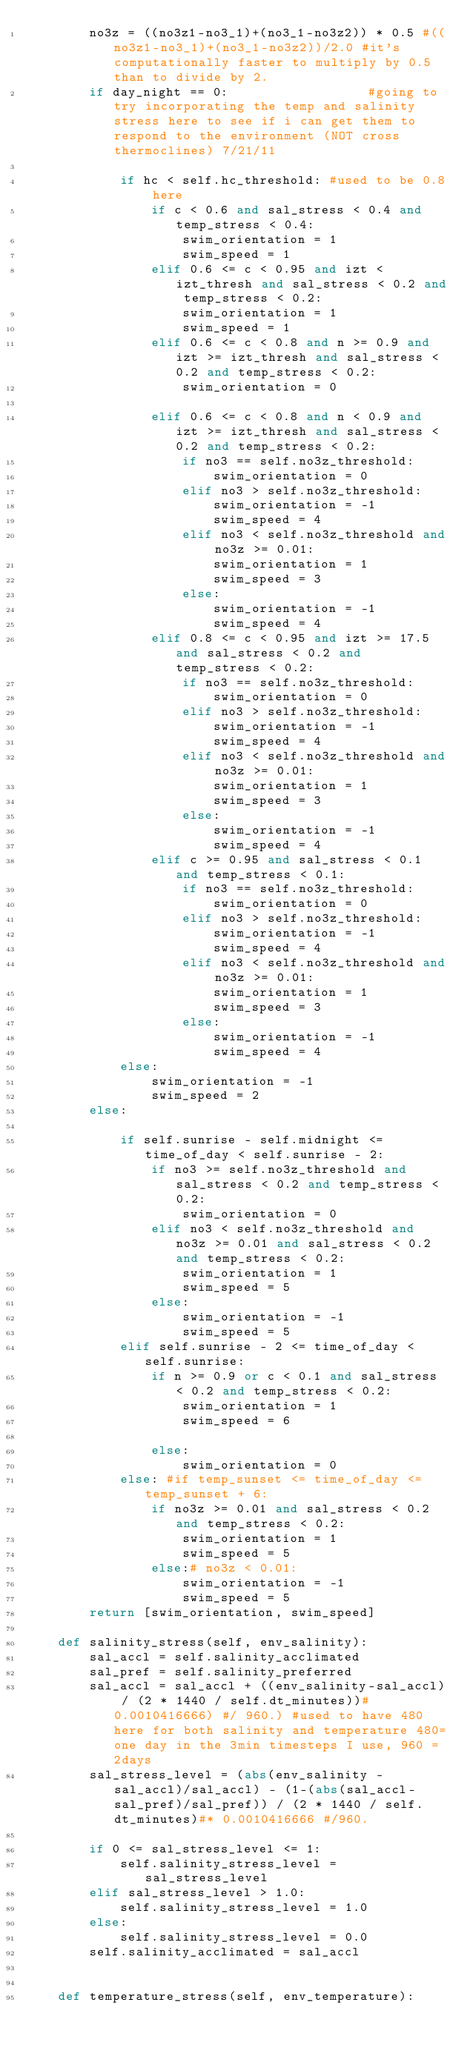Convert code to text. <code><loc_0><loc_0><loc_500><loc_500><_Python_>        no3z = ((no3z1-no3_1)+(no3_1-no3z2)) * 0.5 #((no3z1-no3_1)+(no3_1-no3z2))/2.0 #it's computationally faster to multiply by 0.5 than to divide by 2.
        if day_night == 0:                  #going to try incorporating the temp and salinity stress here to see if i can get them to respond to the environment (NOT cross thermoclines) 7/21/11
            
            if hc < self.hc_threshold: #used to be 0.8 here
                if c < 0.6 and sal_stress < 0.4 and temp_stress < 0.4:
                    swim_orientation = 1
                    swim_speed = 1
                elif 0.6 <= c < 0.95 and izt < izt_thresh and sal_stress < 0.2 and temp_stress < 0.2:
                    swim_orientation = 1
                    swim_speed = 1
                elif 0.6 <= c < 0.8 and n >= 0.9 and izt >= izt_thresh and sal_stress < 0.2 and temp_stress < 0.2:
                    swim_orientation = 0
                
                elif 0.6 <= c < 0.8 and n < 0.9 and izt >= izt_thresh and sal_stress < 0.2 and temp_stress < 0.2:
                    if no3 == self.no3z_threshold:
                        swim_orientation = 0
                    elif no3 > self.no3z_threshold:
                        swim_orientation = -1
                        swim_speed = 4
                    elif no3 < self.no3z_threshold and no3z >= 0.01:
                        swim_orientation = 1
                        swim_speed = 3
                    else:
                        swim_orientation = -1
                        swim_speed = 4
                elif 0.8 <= c < 0.95 and izt >= 17.5 and sal_stress < 0.2 and temp_stress < 0.2:
                    if no3 == self.no3z_threshold:
                        swim_orientation = 0
                    elif no3 > self.no3z_threshold:
                        swim_orientation = -1
                        swim_speed = 4
                    elif no3 < self.no3z_threshold and no3z >= 0.01:
                        swim_orientation = 1
                        swim_speed = 3
                    else:
                        swim_orientation = -1
                        swim_speed = 4
                elif c >= 0.95 and sal_stress < 0.1 and temp_stress < 0.1:
                    if no3 == self.no3z_threshold:
                        swim_orientation = 0
                    elif no3 > self.no3z_threshold:
                        swim_orientation = -1
                        swim_speed = 4
                    elif no3 < self.no3z_threshold and no3z >= 0.01:
                        swim_orientation = 1
                        swim_speed = 3
                    else:
                        swim_orientation = -1
                        swim_speed = 4
            else:
                swim_orientation = -1
                swim_speed = 2
        else:
            
            if self.sunrise - self.midnight <= time_of_day < self.sunrise - 2:
                if no3 >= self.no3z_threshold and sal_stress < 0.2 and temp_stress < 0.2:
                    swim_orientation = 0
                elif no3 < self.no3z_threshold and no3z >= 0.01 and sal_stress < 0.2 and temp_stress < 0.2:
                    swim_orientation = 1
                    swim_speed = 5
                else: 
                    swim_orientation = -1
                    swim_speed = 5
            elif self.sunrise - 2 <= time_of_day < self.sunrise:
                if n >= 0.9 or c < 0.1 and sal_stress < 0.2 and temp_stress < 0.2:
                    swim_orientation = 1
                    swim_speed = 6
                
                else:
                    swim_orientation = 0
            else: #if temp_sunset <= time_of_day <= temp_sunset + 6:
                if no3z >= 0.01 and sal_stress < 0.2 and temp_stress < 0.2:
                    swim_orientation = 1
                    swim_speed = 5
                else:# no3z < 0.01:
                    swim_orientation = -1
                    swim_speed = 5
        return [swim_orientation, swim_speed]

    def salinity_stress(self, env_salinity):
        sal_accl = self.salinity_acclimated
        sal_pref = self.salinity_preferred
        sal_accl = sal_accl + ((env_salinity-sal_accl) / (2 * 1440 / self.dt_minutes))#0.0010416666) #/ 960.) #used to have 480 here for both salinity and temperature 480=one day in the 3min timesteps I use, 960 = 2days
        sal_stress_level = (abs(env_salinity - sal_accl)/sal_accl) - (1-(abs(sal_accl-sal_pref)/sal_pref)) / (2 * 1440 / self.dt_minutes)#* 0.0010416666 #/960.
        
        if 0 <= sal_stress_level <= 1:
            self.salinity_stress_level = sal_stress_level
        elif sal_stress_level > 1.0:
            self.salinity_stress_level = 1.0
        else:
            self.salinity_stress_level = 0.0
        self.salinity_acclimated = sal_accl
        
    
    def temperature_stress(self, env_temperature):</code> 